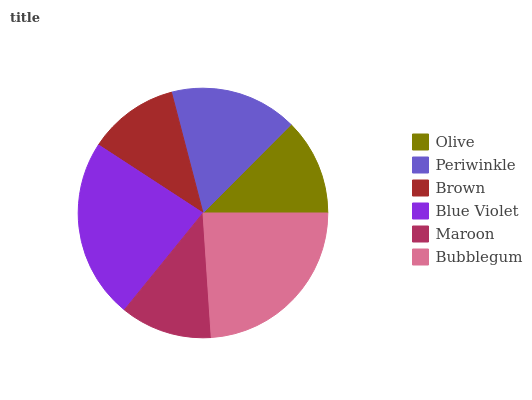Is Brown the minimum?
Answer yes or no. Yes. Is Bubblegum the maximum?
Answer yes or no. Yes. Is Periwinkle the minimum?
Answer yes or no. No. Is Periwinkle the maximum?
Answer yes or no. No. Is Periwinkle greater than Olive?
Answer yes or no. Yes. Is Olive less than Periwinkle?
Answer yes or no. Yes. Is Olive greater than Periwinkle?
Answer yes or no. No. Is Periwinkle less than Olive?
Answer yes or no. No. Is Periwinkle the high median?
Answer yes or no. Yes. Is Olive the low median?
Answer yes or no. Yes. Is Brown the high median?
Answer yes or no. No. Is Blue Violet the low median?
Answer yes or no. No. 